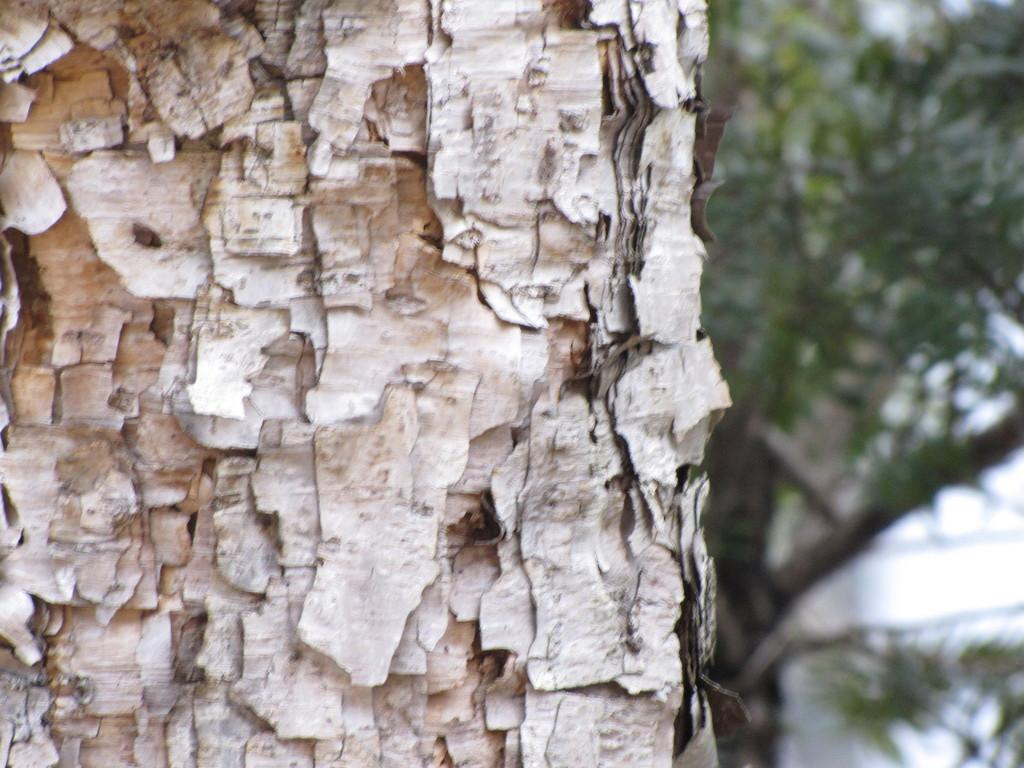What type of natural elements can be seen in the image? There are trees in the image. How would you describe the background of the image? The background of the image is blurred. What type of business is being conducted by the father in the image? There is no father or business activity present in the image. How does the brain function in the image? There is no brain present in the image. 